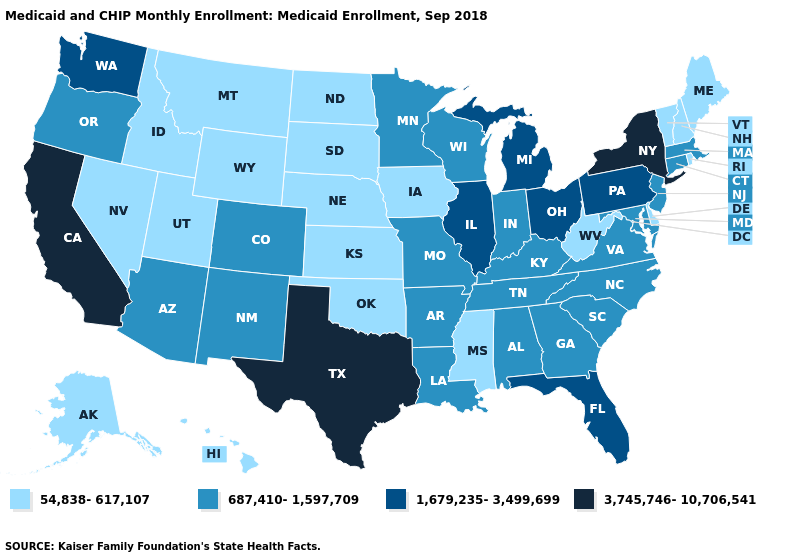Name the states that have a value in the range 1,679,235-3,499,699?
Be succinct. Florida, Illinois, Michigan, Ohio, Pennsylvania, Washington. What is the value of Delaware?
Concise answer only. 54,838-617,107. Name the states that have a value in the range 687,410-1,597,709?
Answer briefly. Alabama, Arizona, Arkansas, Colorado, Connecticut, Georgia, Indiana, Kentucky, Louisiana, Maryland, Massachusetts, Minnesota, Missouri, New Jersey, New Mexico, North Carolina, Oregon, South Carolina, Tennessee, Virginia, Wisconsin. Does Kansas have the lowest value in the USA?
Be succinct. Yes. Is the legend a continuous bar?
Keep it brief. No. What is the value of Nevada?
Answer briefly. 54,838-617,107. Which states have the lowest value in the MidWest?
Give a very brief answer. Iowa, Kansas, Nebraska, North Dakota, South Dakota. Does Washington have a lower value than New Mexico?
Short answer required. No. What is the lowest value in the West?
Give a very brief answer. 54,838-617,107. Does the first symbol in the legend represent the smallest category?
Quick response, please. Yes. Name the states that have a value in the range 54,838-617,107?
Keep it brief. Alaska, Delaware, Hawaii, Idaho, Iowa, Kansas, Maine, Mississippi, Montana, Nebraska, Nevada, New Hampshire, North Dakota, Oklahoma, Rhode Island, South Dakota, Utah, Vermont, West Virginia, Wyoming. What is the value of Utah?
Short answer required. 54,838-617,107. Which states have the lowest value in the Northeast?
Give a very brief answer. Maine, New Hampshire, Rhode Island, Vermont. Among the states that border Wyoming , does Colorado have the highest value?
Be succinct. Yes. What is the value of Ohio?
Keep it brief. 1,679,235-3,499,699. 